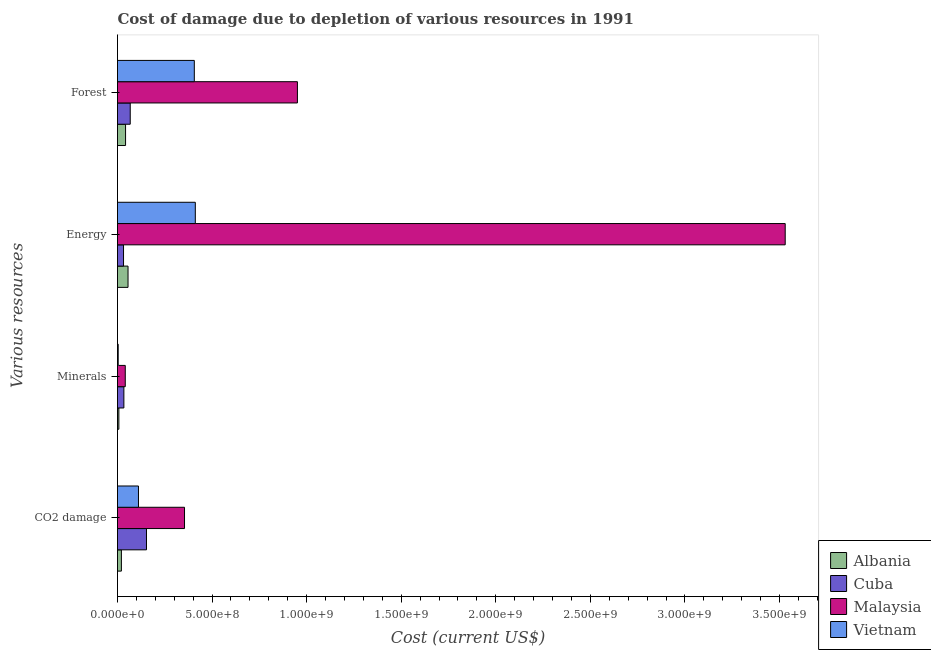How many groups of bars are there?
Keep it short and to the point. 4. How many bars are there on the 2nd tick from the bottom?
Your answer should be compact. 4. What is the label of the 4th group of bars from the top?
Keep it short and to the point. CO2 damage. What is the cost of damage due to depletion of energy in Albania?
Provide a succinct answer. 5.56e+07. Across all countries, what is the maximum cost of damage due to depletion of coal?
Offer a terse response. 3.54e+08. Across all countries, what is the minimum cost of damage due to depletion of coal?
Your answer should be compact. 2.05e+07. In which country was the cost of damage due to depletion of coal maximum?
Ensure brevity in your answer.  Malaysia. In which country was the cost of damage due to depletion of forests minimum?
Ensure brevity in your answer.  Albania. What is the total cost of damage due to depletion of forests in the graph?
Your response must be concise. 1.47e+09. What is the difference between the cost of damage due to depletion of energy in Albania and that in Cuba?
Offer a terse response. 2.38e+07. What is the difference between the cost of damage due to depletion of energy in Cuba and the cost of damage due to depletion of coal in Vietnam?
Offer a very short reply. -7.90e+07. What is the average cost of damage due to depletion of forests per country?
Provide a succinct answer. 3.67e+08. What is the difference between the cost of damage due to depletion of coal and cost of damage due to depletion of energy in Cuba?
Ensure brevity in your answer.  1.21e+08. In how many countries, is the cost of damage due to depletion of energy greater than 1700000000 US$?
Your answer should be compact. 1. What is the ratio of the cost of damage due to depletion of minerals in Cuba to that in Vietnam?
Your response must be concise. 9.09. Is the cost of damage due to depletion of forests in Malaysia less than that in Albania?
Provide a succinct answer. No. What is the difference between the highest and the second highest cost of damage due to depletion of coal?
Your answer should be very brief. 2.01e+08. What is the difference between the highest and the lowest cost of damage due to depletion of forests?
Ensure brevity in your answer.  9.09e+08. In how many countries, is the cost of damage due to depletion of coal greater than the average cost of damage due to depletion of coal taken over all countries?
Offer a terse response. 1. Is the sum of the cost of damage due to depletion of coal in Vietnam and Cuba greater than the maximum cost of damage due to depletion of energy across all countries?
Ensure brevity in your answer.  No. What does the 4th bar from the top in Energy represents?
Give a very brief answer. Albania. What does the 4th bar from the bottom in Minerals represents?
Provide a succinct answer. Vietnam. Is it the case that in every country, the sum of the cost of damage due to depletion of coal and cost of damage due to depletion of minerals is greater than the cost of damage due to depletion of energy?
Give a very brief answer. No. How many bars are there?
Offer a very short reply. 16. Are all the bars in the graph horizontal?
Give a very brief answer. Yes. What is the difference between two consecutive major ticks on the X-axis?
Give a very brief answer. 5.00e+08. Does the graph contain any zero values?
Provide a succinct answer. No. Does the graph contain grids?
Keep it short and to the point. No. How many legend labels are there?
Provide a succinct answer. 4. How are the legend labels stacked?
Ensure brevity in your answer.  Vertical. What is the title of the graph?
Provide a short and direct response. Cost of damage due to depletion of various resources in 1991 . Does "Equatorial Guinea" appear as one of the legend labels in the graph?
Provide a succinct answer. No. What is the label or title of the X-axis?
Your answer should be compact. Cost (current US$). What is the label or title of the Y-axis?
Your answer should be compact. Various resources. What is the Cost (current US$) in Albania in CO2 damage?
Keep it short and to the point. 2.05e+07. What is the Cost (current US$) in Cuba in CO2 damage?
Your response must be concise. 1.53e+08. What is the Cost (current US$) in Malaysia in CO2 damage?
Keep it short and to the point. 3.54e+08. What is the Cost (current US$) in Vietnam in CO2 damage?
Provide a short and direct response. 1.11e+08. What is the Cost (current US$) in Albania in Minerals?
Give a very brief answer. 7.19e+06. What is the Cost (current US$) in Cuba in Minerals?
Your response must be concise. 3.37e+07. What is the Cost (current US$) in Malaysia in Minerals?
Provide a succinct answer. 4.10e+07. What is the Cost (current US$) in Vietnam in Minerals?
Offer a very short reply. 3.71e+06. What is the Cost (current US$) in Albania in Energy?
Make the answer very short. 5.56e+07. What is the Cost (current US$) of Cuba in Energy?
Provide a short and direct response. 3.18e+07. What is the Cost (current US$) in Malaysia in Energy?
Provide a short and direct response. 3.53e+09. What is the Cost (current US$) in Vietnam in Energy?
Ensure brevity in your answer.  4.11e+08. What is the Cost (current US$) of Albania in Forest?
Offer a very short reply. 4.26e+07. What is the Cost (current US$) in Cuba in Forest?
Offer a very short reply. 6.73e+07. What is the Cost (current US$) of Malaysia in Forest?
Offer a terse response. 9.51e+08. What is the Cost (current US$) of Vietnam in Forest?
Offer a terse response. 4.06e+08. Across all Various resources, what is the maximum Cost (current US$) of Albania?
Ensure brevity in your answer.  5.56e+07. Across all Various resources, what is the maximum Cost (current US$) in Cuba?
Your answer should be compact. 1.53e+08. Across all Various resources, what is the maximum Cost (current US$) of Malaysia?
Your answer should be very brief. 3.53e+09. Across all Various resources, what is the maximum Cost (current US$) in Vietnam?
Your response must be concise. 4.11e+08. Across all Various resources, what is the minimum Cost (current US$) in Albania?
Provide a short and direct response. 7.19e+06. Across all Various resources, what is the minimum Cost (current US$) in Cuba?
Offer a terse response. 3.18e+07. Across all Various resources, what is the minimum Cost (current US$) in Malaysia?
Provide a succinct answer. 4.10e+07. Across all Various resources, what is the minimum Cost (current US$) of Vietnam?
Provide a short and direct response. 3.71e+06. What is the total Cost (current US$) in Albania in the graph?
Provide a succinct answer. 1.26e+08. What is the total Cost (current US$) of Cuba in the graph?
Your answer should be very brief. 2.86e+08. What is the total Cost (current US$) in Malaysia in the graph?
Make the answer very short. 4.88e+09. What is the total Cost (current US$) in Vietnam in the graph?
Your answer should be compact. 9.32e+08. What is the difference between the Cost (current US$) in Albania in CO2 damage and that in Minerals?
Keep it short and to the point. 1.33e+07. What is the difference between the Cost (current US$) of Cuba in CO2 damage and that in Minerals?
Offer a terse response. 1.20e+08. What is the difference between the Cost (current US$) of Malaysia in CO2 damage and that in Minerals?
Make the answer very short. 3.13e+08. What is the difference between the Cost (current US$) of Vietnam in CO2 damage and that in Minerals?
Provide a short and direct response. 1.07e+08. What is the difference between the Cost (current US$) of Albania in CO2 damage and that in Energy?
Provide a succinct answer. -3.51e+07. What is the difference between the Cost (current US$) in Cuba in CO2 damage and that in Energy?
Keep it short and to the point. 1.21e+08. What is the difference between the Cost (current US$) in Malaysia in CO2 damage and that in Energy?
Your answer should be very brief. -3.18e+09. What is the difference between the Cost (current US$) in Vietnam in CO2 damage and that in Energy?
Give a very brief answer. -3.01e+08. What is the difference between the Cost (current US$) of Albania in CO2 damage and that in Forest?
Your answer should be very brief. -2.21e+07. What is the difference between the Cost (current US$) in Cuba in CO2 damage and that in Forest?
Give a very brief answer. 8.59e+07. What is the difference between the Cost (current US$) in Malaysia in CO2 damage and that in Forest?
Provide a short and direct response. -5.97e+08. What is the difference between the Cost (current US$) in Vietnam in CO2 damage and that in Forest?
Keep it short and to the point. -2.95e+08. What is the difference between the Cost (current US$) of Albania in Minerals and that in Energy?
Provide a short and direct response. -4.84e+07. What is the difference between the Cost (current US$) of Cuba in Minerals and that in Energy?
Your answer should be very brief. 1.83e+06. What is the difference between the Cost (current US$) in Malaysia in Minerals and that in Energy?
Provide a short and direct response. -3.49e+09. What is the difference between the Cost (current US$) of Vietnam in Minerals and that in Energy?
Make the answer very short. -4.08e+08. What is the difference between the Cost (current US$) of Albania in Minerals and that in Forest?
Offer a terse response. -3.54e+07. What is the difference between the Cost (current US$) in Cuba in Minerals and that in Forest?
Offer a very short reply. -3.36e+07. What is the difference between the Cost (current US$) of Malaysia in Minerals and that in Forest?
Offer a terse response. -9.10e+08. What is the difference between the Cost (current US$) in Vietnam in Minerals and that in Forest?
Make the answer very short. -4.02e+08. What is the difference between the Cost (current US$) of Albania in Energy and that in Forest?
Provide a succinct answer. 1.30e+07. What is the difference between the Cost (current US$) of Cuba in Energy and that in Forest?
Ensure brevity in your answer.  -3.55e+07. What is the difference between the Cost (current US$) of Malaysia in Energy and that in Forest?
Offer a terse response. 2.58e+09. What is the difference between the Cost (current US$) in Vietnam in Energy and that in Forest?
Offer a terse response. 5.24e+06. What is the difference between the Cost (current US$) in Albania in CO2 damage and the Cost (current US$) in Cuba in Minerals?
Provide a short and direct response. -1.31e+07. What is the difference between the Cost (current US$) in Albania in CO2 damage and the Cost (current US$) in Malaysia in Minerals?
Make the answer very short. -2.05e+07. What is the difference between the Cost (current US$) in Albania in CO2 damage and the Cost (current US$) in Vietnam in Minerals?
Provide a short and direct response. 1.68e+07. What is the difference between the Cost (current US$) in Cuba in CO2 damage and the Cost (current US$) in Malaysia in Minerals?
Provide a succinct answer. 1.12e+08. What is the difference between the Cost (current US$) in Cuba in CO2 damage and the Cost (current US$) in Vietnam in Minerals?
Provide a short and direct response. 1.49e+08. What is the difference between the Cost (current US$) of Malaysia in CO2 damage and the Cost (current US$) of Vietnam in Minerals?
Offer a very short reply. 3.51e+08. What is the difference between the Cost (current US$) of Albania in CO2 damage and the Cost (current US$) of Cuba in Energy?
Provide a succinct answer. -1.13e+07. What is the difference between the Cost (current US$) of Albania in CO2 damage and the Cost (current US$) of Malaysia in Energy?
Offer a very short reply. -3.51e+09. What is the difference between the Cost (current US$) in Albania in CO2 damage and the Cost (current US$) in Vietnam in Energy?
Provide a short and direct response. -3.91e+08. What is the difference between the Cost (current US$) of Cuba in CO2 damage and the Cost (current US$) of Malaysia in Energy?
Offer a terse response. -3.38e+09. What is the difference between the Cost (current US$) of Cuba in CO2 damage and the Cost (current US$) of Vietnam in Energy?
Provide a short and direct response. -2.58e+08. What is the difference between the Cost (current US$) in Malaysia in CO2 damage and the Cost (current US$) in Vietnam in Energy?
Provide a short and direct response. -5.70e+07. What is the difference between the Cost (current US$) in Albania in CO2 damage and the Cost (current US$) in Cuba in Forest?
Offer a terse response. -4.68e+07. What is the difference between the Cost (current US$) of Albania in CO2 damage and the Cost (current US$) of Malaysia in Forest?
Your response must be concise. -9.31e+08. What is the difference between the Cost (current US$) of Albania in CO2 damage and the Cost (current US$) of Vietnam in Forest?
Provide a short and direct response. -3.86e+08. What is the difference between the Cost (current US$) of Cuba in CO2 damage and the Cost (current US$) of Malaysia in Forest?
Your answer should be compact. -7.98e+08. What is the difference between the Cost (current US$) of Cuba in CO2 damage and the Cost (current US$) of Vietnam in Forest?
Provide a short and direct response. -2.53e+08. What is the difference between the Cost (current US$) in Malaysia in CO2 damage and the Cost (current US$) in Vietnam in Forest?
Ensure brevity in your answer.  -5.18e+07. What is the difference between the Cost (current US$) in Albania in Minerals and the Cost (current US$) in Cuba in Energy?
Your answer should be compact. -2.46e+07. What is the difference between the Cost (current US$) in Albania in Minerals and the Cost (current US$) in Malaysia in Energy?
Give a very brief answer. -3.52e+09. What is the difference between the Cost (current US$) of Albania in Minerals and the Cost (current US$) of Vietnam in Energy?
Provide a succinct answer. -4.04e+08. What is the difference between the Cost (current US$) of Cuba in Minerals and the Cost (current US$) of Malaysia in Energy?
Your answer should be very brief. -3.50e+09. What is the difference between the Cost (current US$) in Cuba in Minerals and the Cost (current US$) in Vietnam in Energy?
Your answer should be compact. -3.78e+08. What is the difference between the Cost (current US$) of Malaysia in Minerals and the Cost (current US$) of Vietnam in Energy?
Give a very brief answer. -3.70e+08. What is the difference between the Cost (current US$) of Albania in Minerals and the Cost (current US$) of Cuba in Forest?
Provide a short and direct response. -6.01e+07. What is the difference between the Cost (current US$) of Albania in Minerals and the Cost (current US$) of Malaysia in Forest?
Keep it short and to the point. -9.44e+08. What is the difference between the Cost (current US$) of Albania in Minerals and the Cost (current US$) of Vietnam in Forest?
Offer a terse response. -3.99e+08. What is the difference between the Cost (current US$) in Cuba in Minerals and the Cost (current US$) in Malaysia in Forest?
Offer a very short reply. -9.18e+08. What is the difference between the Cost (current US$) in Cuba in Minerals and the Cost (current US$) in Vietnam in Forest?
Offer a terse response. -3.72e+08. What is the difference between the Cost (current US$) in Malaysia in Minerals and the Cost (current US$) in Vietnam in Forest?
Your answer should be compact. -3.65e+08. What is the difference between the Cost (current US$) of Albania in Energy and the Cost (current US$) of Cuba in Forest?
Make the answer very short. -1.16e+07. What is the difference between the Cost (current US$) in Albania in Energy and the Cost (current US$) in Malaysia in Forest?
Your answer should be compact. -8.96e+08. What is the difference between the Cost (current US$) in Albania in Energy and the Cost (current US$) in Vietnam in Forest?
Provide a succinct answer. -3.50e+08. What is the difference between the Cost (current US$) of Cuba in Energy and the Cost (current US$) of Malaysia in Forest?
Your response must be concise. -9.19e+08. What is the difference between the Cost (current US$) of Cuba in Energy and the Cost (current US$) of Vietnam in Forest?
Your response must be concise. -3.74e+08. What is the difference between the Cost (current US$) of Malaysia in Energy and the Cost (current US$) of Vietnam in Forest?
Make the answer very short. 3.12e+09. What is the average Cost (current US$) of Albania per Various resources?
Ensure brevity in your answer.  3.15e+07. What is the average Cost (current US$) in Cuba per Various resources?
Your answer should be compact. 7.15e+07. What is the average Cost (current US$) in Malaysia per Various resources?
Ensure brevity in your answer.  1.22e+09. What is the average Cost (current US$) in Vietnam per Various resources?
Provide a short and direct response. 2.33e+08. What is the difference between the Cost (current US$) in Albania and Cost (current US$) in Cuba in CO2 damage?
Provide a short and direct response. -1.33e+08. What is the difference between the Cost (current US$) of Albania and Cost (current US$) of Malaysia in CO2 damage?
Keep it short and to the point. -3.34e+08. What is the difference between the Cost (current US$) in Albania and Cost (current US$) in Vietnam in CO2 damage?
Your response must be concise. -9.03e+07. What is the difference between the Cost (current US$) in Cuba and Cost (current US$) in Malaysia in CO2 damage?
Keep it short and to the point. -2.01e+08. What is the difference between the Cost (current US$) in Cuba and Cost (current US$) in Vietnam in CO2 damage?
Ensure brevity in your answer.  4.24e+07. What is the difference between the Cost (current US$) of Malaysia and Cost (current US$) of Vietnam in CO2 damage?
Provide a short and direct response. 2.44e+08. What is the difference between the Cost (current US$) of Albania and Cost (current US$) of Cuba in Minerals?
Your answer should be very brief. -2.65e+07. What is the difference between the Cost (current US$) of Albania and Cost (current US$) of Malaysia in Minerals?
Make the answer very short. -3.38e+07. What is the difference between the Cost (current US$) of Albania and Cost (current US$) of Vietnam in Minerals?
Offer a terse response. 3.48e+06. What is the difference between the Cost (current US$) of Cuba and Cost (current US$) of Malaysia in Minerals?
Provide a succinct answer. -7.37e+06. What is the difference between the Cost (current US$) of Cuba and Cost (current US$) of Vietnam in Minerals?
Make the answer very short. 3.00e+07. What is the difference between the Cost (current US$) in Malaysia and Cost (current US$) in Vietnam in Minerals?
Your answer should be compact. 3.73e+07. What is the difference between the Cost (current US$) in Albania and Cost (current US$) in Cuba in Energy?
Your answer should be compact. 2.38e+07. What is the difference between the Cost (current US$) of Albania and Cost (current US$) of Malaysia in Energy?
Offer a very short reply. -3.47e+09. What is the difference between the Cost (current US$) of Albania and Cost (current US$) of Vietnam in Energy?
Ensure brevity in your answer.  -3.56e+08. What is the difference between the Cost (current US$) of Cuba and Cost (current US$) of Malaysia in Energy?
Your answer should be compact. -3.50e+09. What is the difference between the Cost (current US$) of Cuba and Cost (current US$) of Vietnam in Energy?
Your answer should be compact. -3.80e+08. What is the difference between the Cost (current US$) of Malaysia and Cost (current US$) of Vietnam in Energy?
Provide a short and direct response. 3.12e+09. What is the difference between the Cost (current US$) in Albania and Cost (current US$) in Cuba in Forest?
Make the answer very short. -2.46e+07. What is the difference between the Cost (current US$) of Albania and Cost (current US$) of Malaysia in Forest?
Offer a very short reply. -9.09e+08. What is the difference between the Cost (current US$) in Albania and Cost (current US$) in Vietnam in Forest?
Keep it short and to the point. -3.63e+08. What is the difference between the Cost (current US$) of Cuba and Cost (current US$) of Malaysia in Forest?
Your response must be concise. -8.84e+08. What is the difference between the Cost (current US$) of Cuba and Cost (current US$) of Vietnam in Forest?
Your answer should be compact. -3.39e+08. What is the difference between the Cost (current US$) in Malaysia and Cost (current US$) in Vietnam in Forest?
Your answer should be compact. 5.45e+08. What is the ratio of the Cost (current US$) of Albania in CO2 damage to that in Minerals?
Provide a succinct answer. 2.85. What is the ratio of the Cost (current US$) of Cuba in CO2 damage to that in Minerals?
Make the answer very short. 4.55. What is the ratio of the Cost (current US$) of Malaysia in CO2 damage to that in Minerals?
Your answer should be very brief. 8.64. What is the ratio of the Cost (current US$) in Vietnam in CO2 damage to that in Minerals?
Provide a short and direct response. 29.91. What is the ratio of the Cost (current US$) in Albania in CO2 damage to that in Energy?
Provide a succinct answer. 0.37. What is the ratio of the Cost (current US$) of Cuba in CO2 damage to that in Energy?
Ensure brevity in your answer.  4.81. What is the ratio of the Cost (current US$) of Malaysia in CO2 damage to that in Energy?
Keep it short and to the point. 0.1. What is the ratio of the Cost (current US$) of Vietnam in CO2 damage to that in Energy?
Offer a terse response. 0.27. What is the ratio of the Cost (current US$) in Albania in CO2 damage to that in Forest?
Your answer should be very brief. 0.48. What is the ratio of the Cost (current US$) in Cuba in CO2 damage to that in Forest?
Give a very brief answer. 2.28. What is the ratio of the Cost (current US$) in Malaysia in CO2 damage to that in Forest?
Your answer should be compact. 0.37. What is the ratio of the Cost (current US$) in Vietnam in CO2 damage to that in Forest?
Ensure brevity in your answer.  0.27. What is the ratio of the Cost (current US$) in Albania in Minerals to that in Energy?
Your answer should be compact. 0.13. What is the ratio of the Cost (current US$) of Cuba in Minerals to that in Energy?
Your answer should be compact. 1.06. What is the ratio of the Cost (current US$) in Malaysia in Minerals to that in Energy?
Offer a very short reply. 0.01. What is the ratio of the Cost (current US$) in Vietnam in Minerals to that in Energy?
Keep it short and to the point. 0.01. What is the ratio of the Cost (current US$) of Albania in Minerals to that in Forest?
Keep it short and to the point. 0.17. What is the ratio of the Cost (current US$) of Cuba in Minerals to that in Forest?
Your response must be concise. 0.5. What is the ratio of the Cost (current US$) of Malaysia in Minerals to that in Forest?
Your answer should be compact. 0.04. What is the ratio of the Cost (current US$) of Vietnam in Minerals to that in Forest?
Your response must be concise. 0.01. What is the ratio of the Cost (current US$) in Albania in Energy to that in Forest?
Give a very brief answer. 1.3. What is the ratio of the Cost (current US$) in Cuba in Energy to that in Forest?
Give a very brief answer. 0.47. What is the ratio of the Cost (current US$) in Malaysia in Energy to that in Forest?
Make the answer very short. 3.71. What is the ratio of the Cost (current US$) in Vietnam in Energy to that in Forest?
Your answer should be compact. 1.01. What is the difference between the highest and the second highest Cost (current US$) in Albania?
Offer a very short reply. 1.30e+07. What is the difference between the highest and the second highest Cost (current US$) in Cuba?
Offer a very short reply. 8.59e+07. What is the difference between the highest and the second highest Cost (current US$) of Malaysia?
Your answer should be compact. 2.58e+09. What is the difference between the highest and the second highest Cost (current US$) in Vietnam?
Your answer should be compact. 5.24e+06. What is the difference between the highest and the lowest Cost (current US$) in Albania?
Give a very brief answer. 4.84e+07. What is the difference between the highest and the lowest Cost (current US$) in Cuba?
Give a very brief answer. 1.21e+08. What is the difference between the highest and the lowest Cost (current US$) of Malaysia?
Offer a very short reply. 3.49e+09. What is the difference between the highest and the lowest Cost (current US$) in Vietnam?
Give a very brief answer. 4.08e+08. 